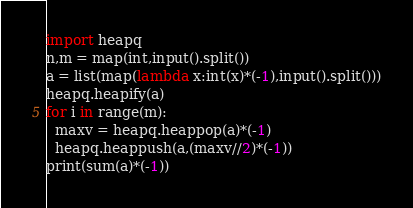Convert code to text. <code><loc_0><loc_0><loc_500><loc_500><_Python_>import heapq
n,m = map(int,input().split())
a = list(map(lambda x:int(x)*(-1),input().split()))
heapq.heapify(a)
for i in range(m):
  maxv = heapq.heappop(a)*(-1)
  heapq.heappush(a,(maxv//2)*(-1))
print(sum(a)*(-1))</code> 